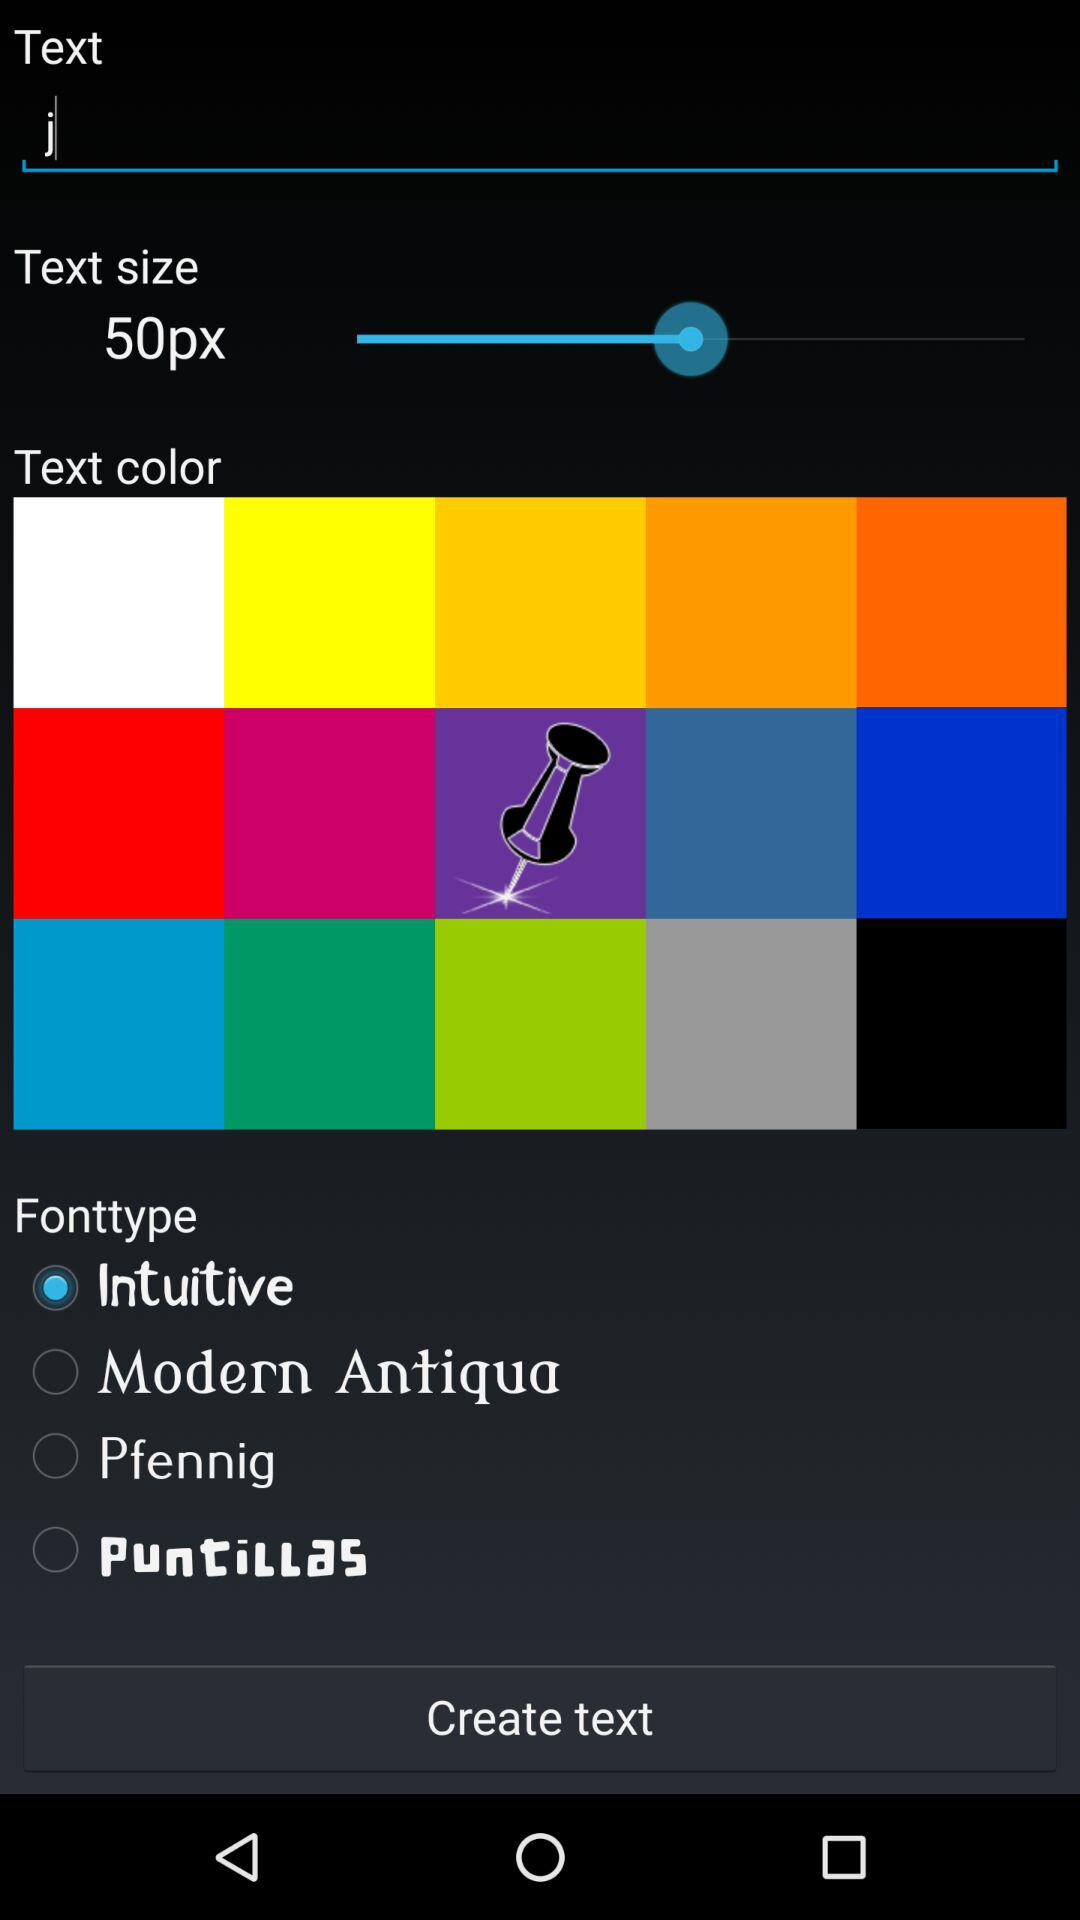How many font options are there?
Answer the question using a single word or phrase. 4 